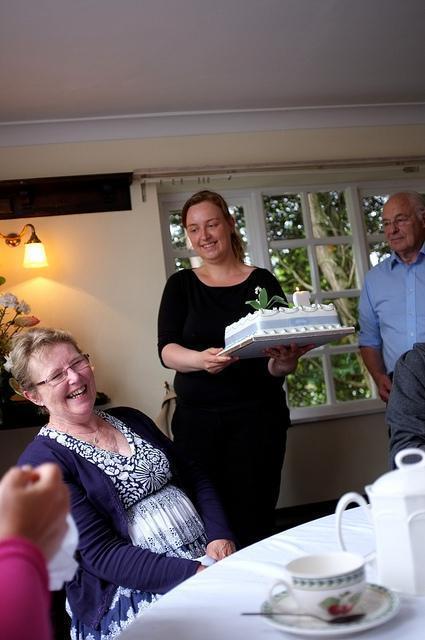How many people are visible?
Give a very brief answer. 5. 